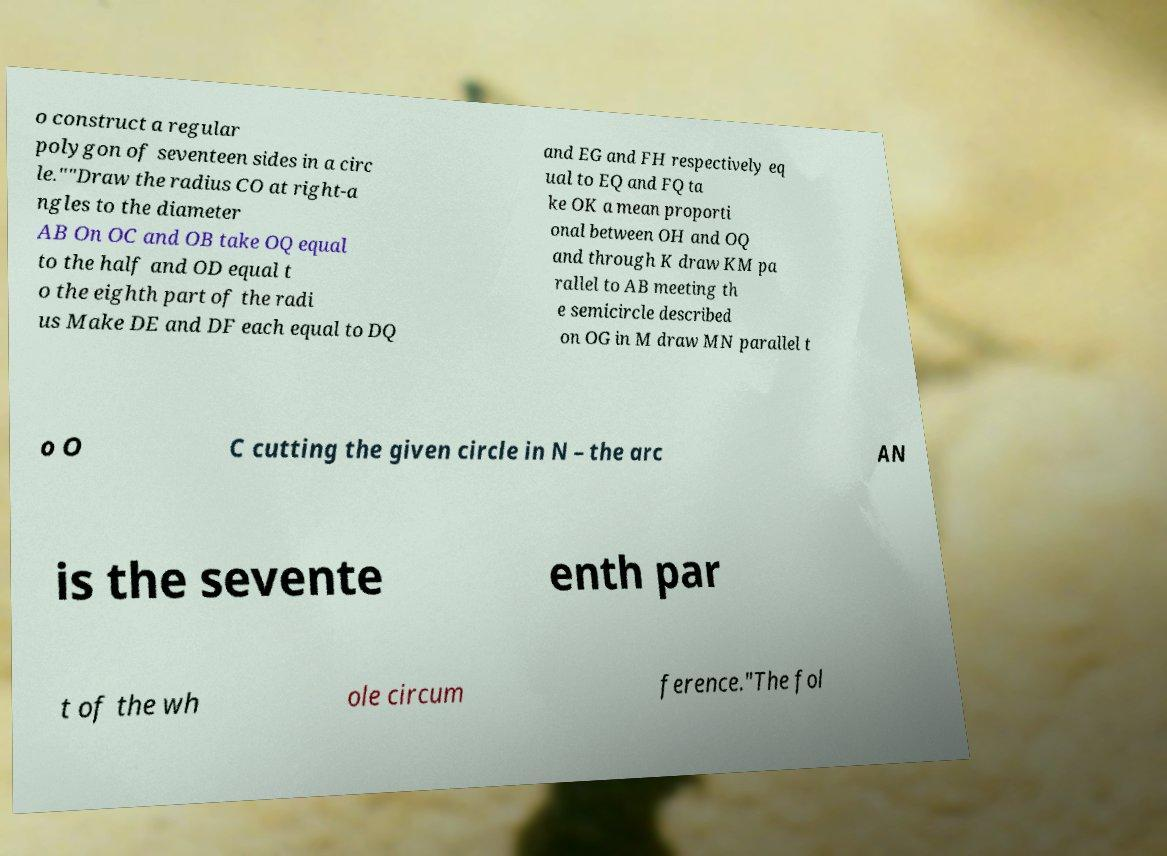Can you read and provide the text displayed in the image?This photo seems to have some interesting text. Can you extract and type it out for me? o construct a regular polygon of seventeen sides in a circ le.""Draw the radius CO at right-a ngles to the diameter AB On OC and OB take OQ equal to the half and OD equal t o the eighth part of the radi us Make DE and DF each equal to DQ and EG and FH respectively eq ual to EQ and FQ ta ke OK a mean proporti onal between OH and OQ and through K draw KM pa rallel to AB meeting th e semicircle described on OG in M draw MN parallel t o O C cutting the given circle in N – the arc AN is the sevente enth par t of the wh ole circum ference."The fol 